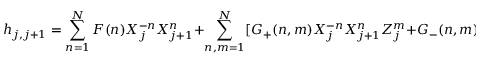<formula> <loc_0><loc_0><loc_500><loc_500>h _ { j , j + 1 } = \sum _ { n = 1 } ^ { N } F ( n ) X _ { j } ^ { - n } X _ { j + 1 } ^ { n } + \sum _ { n , m = 1 } ^ { N } [ G _ { + } ( n , m ) X _ { j } ^ { - n } X _ { j + 1 } ^ { n } Z _ { j } ^ { m } + G _ { - } ( n , m ) X _ { j } ^ { - n } X _ { j + 1 } ^ { n } Z _ { j + 1 } ^ { m } ]</formula> 